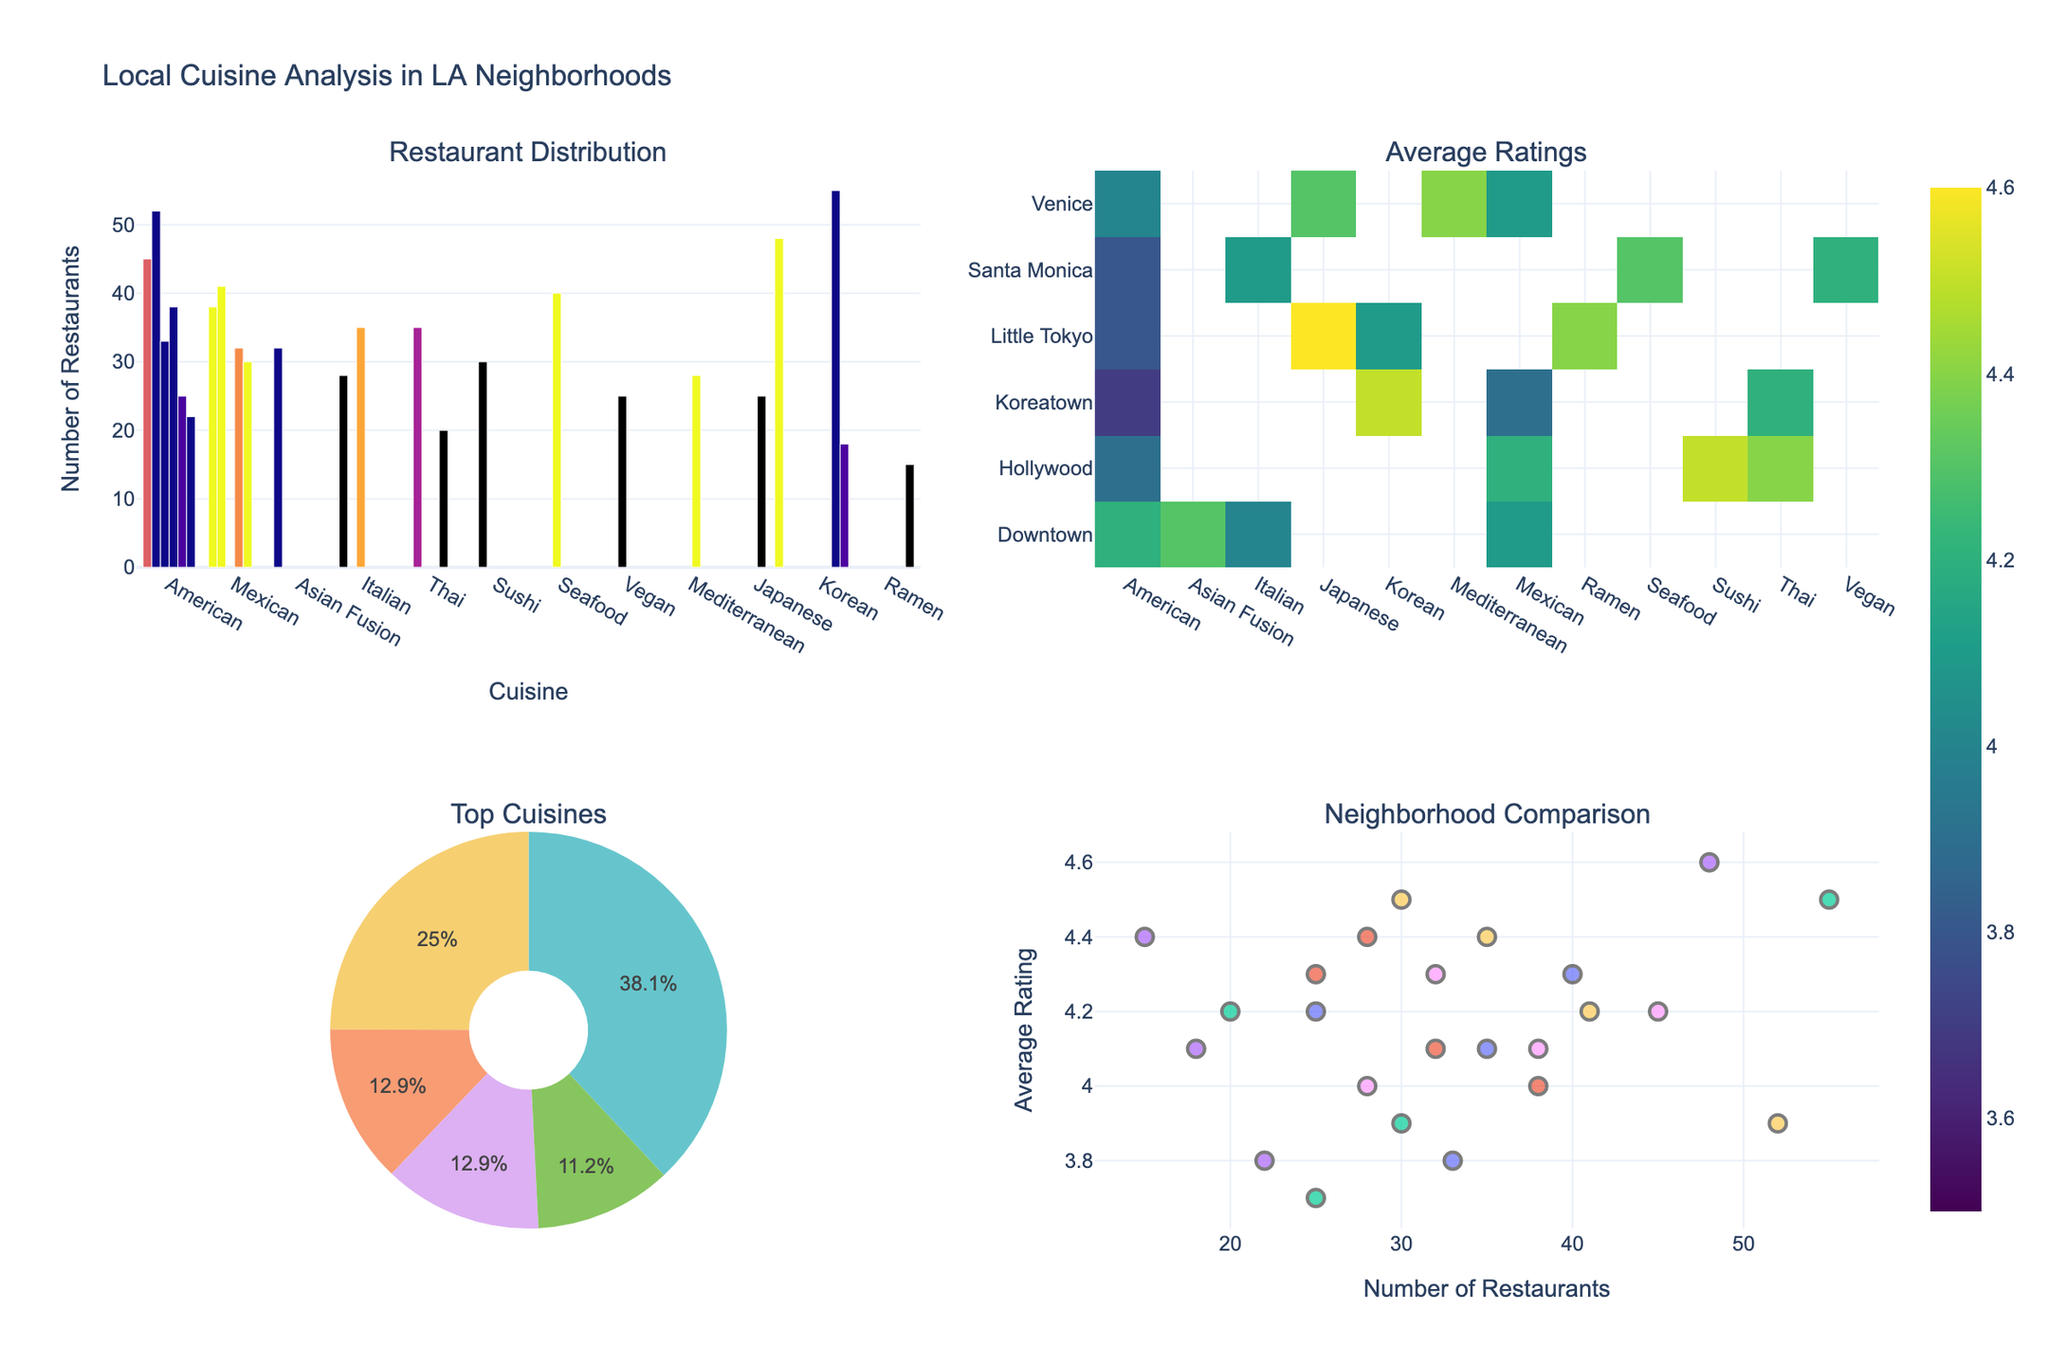Which neighborhood has the most restaurants for American cuisine? According to the bar chart, Hollywood has the highest number of American cuisine restaurants.
Answer: Hollywood What is the average rating for Mediterranean cuisine in Venice? The heatmap shows that Mediterranean cuisine in Venice has an average rating of 4.4.
Answer: 4.4 Which cuisine type has the most significant number of restaurants in the entire dataset? The pie chart indicates that American cuisine has the largest number of restaurants across all neighborhoods.
Answer: American Compare the average ratings of Thai restaurants in Hollywood and Koreatown. Which one is higher? By inspecting the heatmap, Thai restaurants in Hollywood have an average rating of 4.4, whereas in Koreatown, it’s 4.2. Thus, Hollywood Thai restaurants have higher ratings.
Answer: Hollywood Out of the five most common cuisines, which one appears the least in the pie chart? Among the top five cuisines in the pie chart, Vegan has the fewest appearances with a lower proportion.
Answer: Vegan How does the number of Mexican restaurants in Downtown compare to those in Hollywood? The bar chart shows Downtown has 38 Mexican restaurants while Hollywood has 41. Hollywood has more Mexican restaurants.
Answer: Hollywood What is the average rating of restaurants in Little Tokyo for American cuisine compared to Japanese cuisine? By examining the heatmap, American cuisine in Little Tokyo has an average rating of 3.8, while Japanese cuisine has an average rating of 4.6. Japanese cuisine has a higher rating.
Answer: Japanese cuisine What does the scatter plot suggest about the relationship between the number of restaurants and average ratings in Downtown? The scatter plot indicates that Downtown restaurants show a clustering, but overall, higher numbers of restaurants tend to have slightly better average ratings, suggesting a moderate positive relationship.
Answer: Moderate positive relationship Which cuisine in Koreatown has the highest average rating according to the heatmap? The heatmap displays that Korean cuisine in Koreatown has the highest average rating at 4.5.
Answer: Korean What is the average rating of the top three cuisines by restaurant count according to the pie chart? The top three cuisines by restaurant count in the pie chart are American, Mexican, and Seafood. Checking the heatmap and bar chart: American (between 3.7 to 4.2), Mexican (3.9 to 4.1), Seafood (4.3). Average roughly: (4.2+4.1+4.3)/3.
Answer: 4.2 